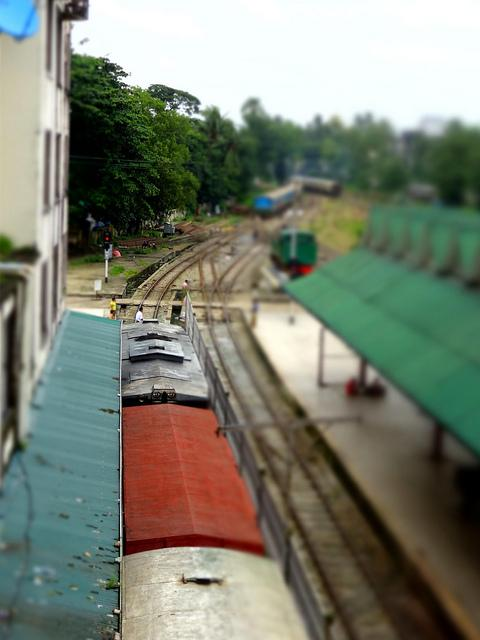Who works at one of these places? conductor 